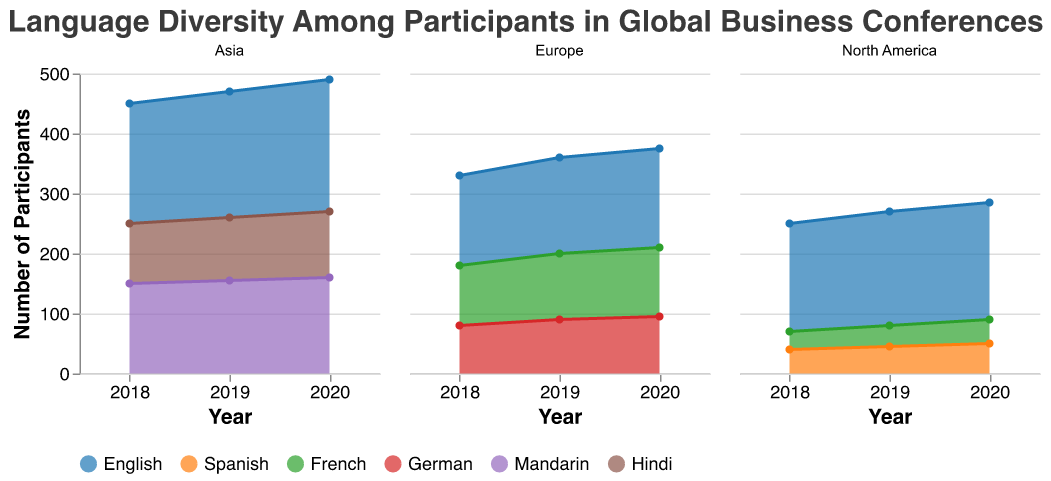What's the total number of participants in North America for 2020? Sum the number of participants for English, Spanish, and French for North America in 2020: 195 + 50 + 40 = 285
Answer: 285 Which region had the highest number of English-speaking participants in 2019? Compare the number of English-speaking participants in 2019 across different regions: North America (190), Europe (160), Asia (210). Asia has the highest number.
Answer: Asia How did the number of German-speaking participants in Europe change from 2018 to 2020? Compare the number of German-speaking participants in Europe in 2018 (80), 2019 (90), and 2020 (95). Calculate the changes: From 2018 to 2019, 90 - 80 = 10; from 2019 to 2020, 95 - 90 = 5.
Answer: Increased by 15 What is the overall trend of Spanish-speaking participants in North America from 2018 to 2020? Identify the number of Spanish-speaking participants in 2018 (40), 2019 (45), and 2020 (50). Observe the trend: 40 to 45 to 50 indicates an increasing trend.
Answer: Increasing In which year did Asia have the most Mandarin-speaking participants? Compare the number of Mandarin-speaking participants in Asia across the years: 2018 (150), 2019 (155), 2020 (160). The highest number is in 2020.
Answer: 2020 Which language had the lowest number of participants in Europe in 2020? Compare the number of participants for different languages in Europe in 2020: English (165), French (115), German (95). German has the lowest number.
Answer: German What's the difference in the number of Hindi-speaking participants in Asia between 2019 and 2020? Subtract the number of Hindi-speaking participants in 2019 (105) from those in 2020 (110): 110 - 105 = 5.
Answer: 5 How does the distribution of language diversity appear from 2018 to 2020 in North America? Observe the area chart for North America from 2018 to 2020. Note the areas corresponding to English, Spanish, and French participants, noting that English has the largest area, followed by Spanish and French.
Answer: English dominates, followed by Spanish and French Which year had the maximum number of participants for all languages combined in Europe? Sum the number of participants for all languages in Europe for each year: 2018 (150 + 100 + 80 = 330), 2019 (160 + 110 + 90 = 360), 2020 (165 + 115 + 95 = 375). The maximum is in 2020.
Answer: 2020 